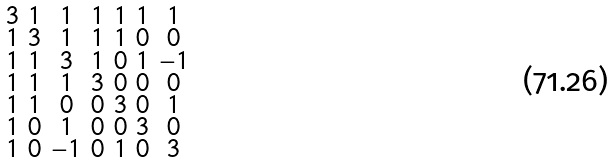<formula> <loc_0><loc_0><loc_500><loc_500>\begin{smallmatrix} 3 & 1 & 1 & 1 & 1 & 1 & 1 \\ 1 & 3 & 1 & 1 & 1 & 0 & 0 \\ 1 & 1 & 3 & 1 & 0 & 1 & - 1 \\ 1 & 1 & 1 & 3 & 0 & 0 & 0 \\ 1 & 1 & 0 & 0 & 3 & 0 & 1 \\ 1 & 0 & 1 & 0 & 0 & 3 & 0 \\ 1 & 0 & - 1 & 0 & 1 & 0 & 3 \end{smallmatrix}</formula> 